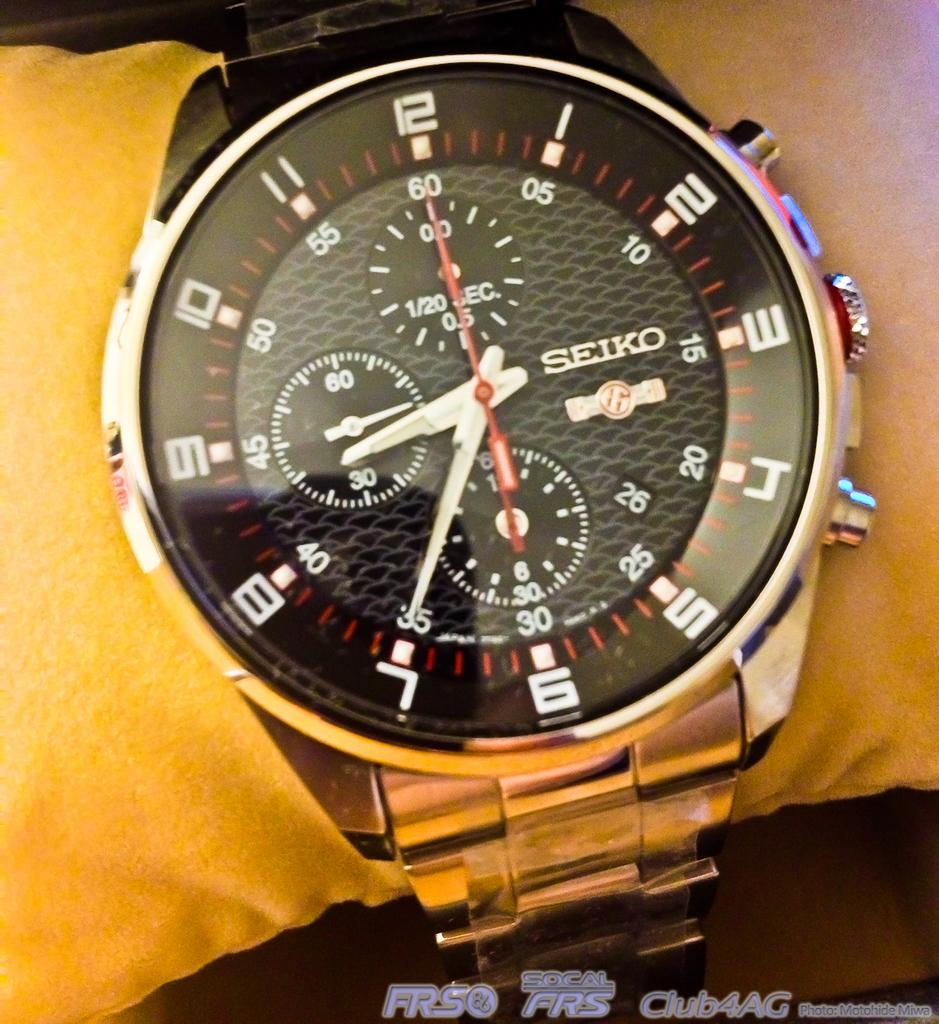<image>
Describe the image concisely. A Seiko watch is worn on the arm of someone wearing a yellow shirt. 